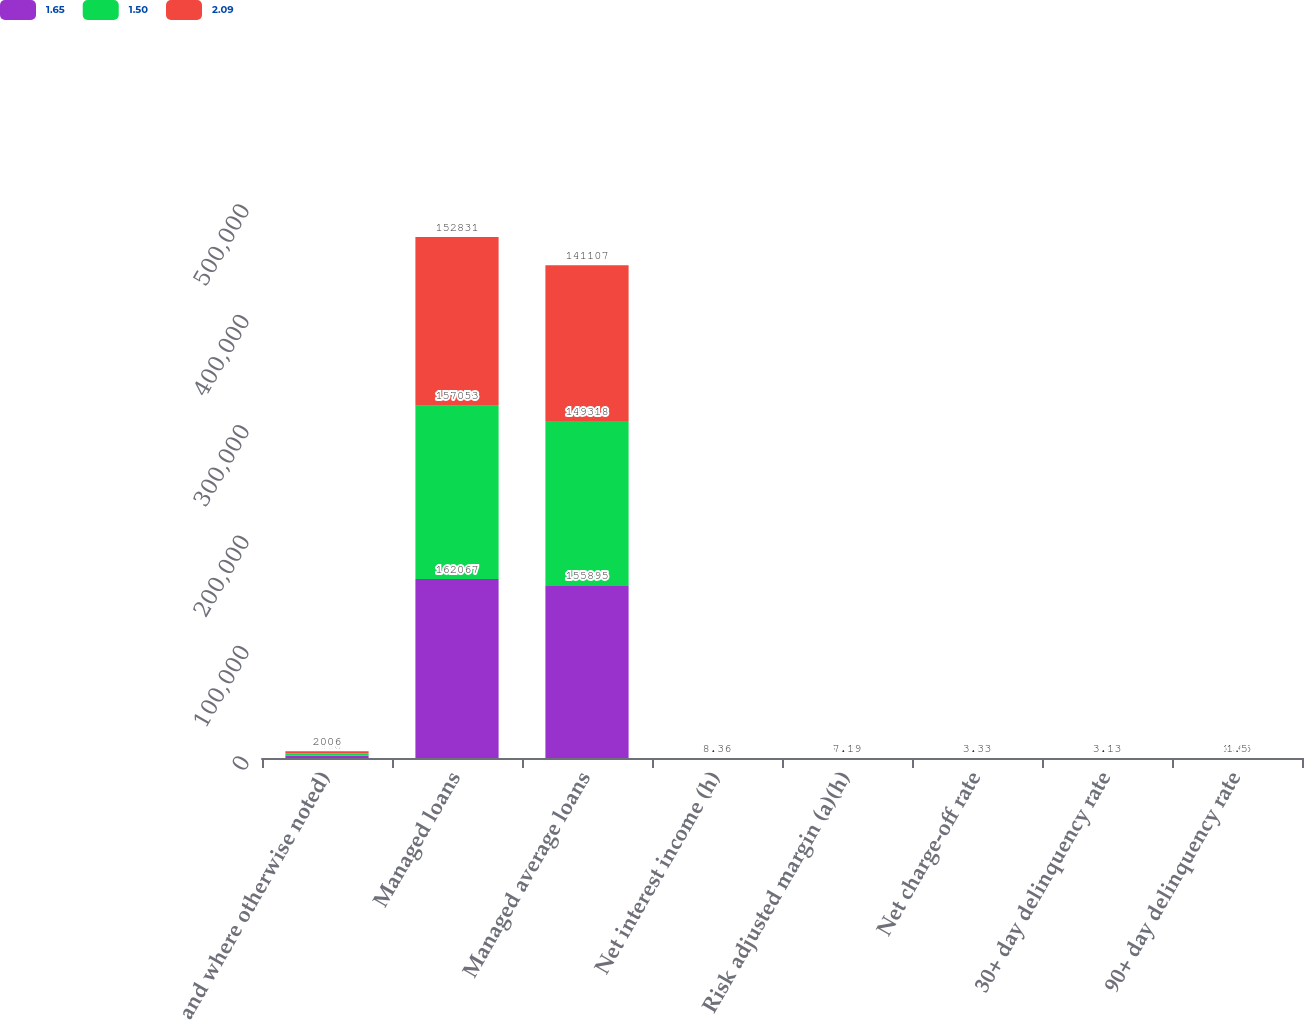Convert chart to OTSL. <chart><loc_0><loc_0><loc_500><loc_500><stacked_bar_chart><ecel><fcel>and where otherwise noted)<fcel>Managed loans<fcel>Managed average loans<fcel>Net interest income (h)<fcel>Risk adjusted margin (a)(h)<fcel>Net charge-off rate<fcel>30+ day delinquency rate<fcel>90+ day delinquency rate<nl><fcel>1.65<fcel>2008<fcel>162067<fcel>155895<fcel>8.16<fcel>3.93<fcel>4.92<fcel>4.36<fcel>2.09<nl><fcel>1.5<fcel>2007<fcel>157053<fcel>149318<fcel>8.16<fcel>6.38<fcel>3.68<fcel>3.48<fcel>1.65<nl><fcel>2.09<fcel>2006<fcel>152831<fcel>141107<fcel>8.36<fcel>7.19<fcel>3.33<fcel>3.13<fcel>1.5<nl></chart> 